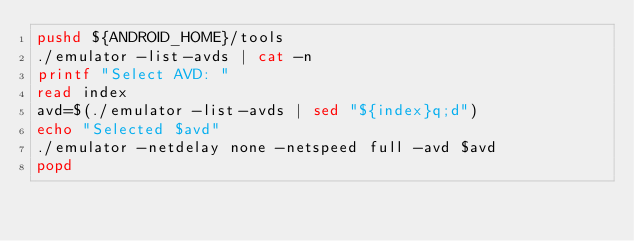<code> <loc_0><loc_0><loc_500><loc_500><_Bash_>pushd ${ANDROID_HOME}/tools
./emulator -list-avds | cat -n
printf "Select AVD: "
read index
avd=$(./emulator -list-avds | sed "${index}q;d")
echo "Selected $avd"
./emulator -netdelay none -netspeed full -avd $avd
popd
</code> 